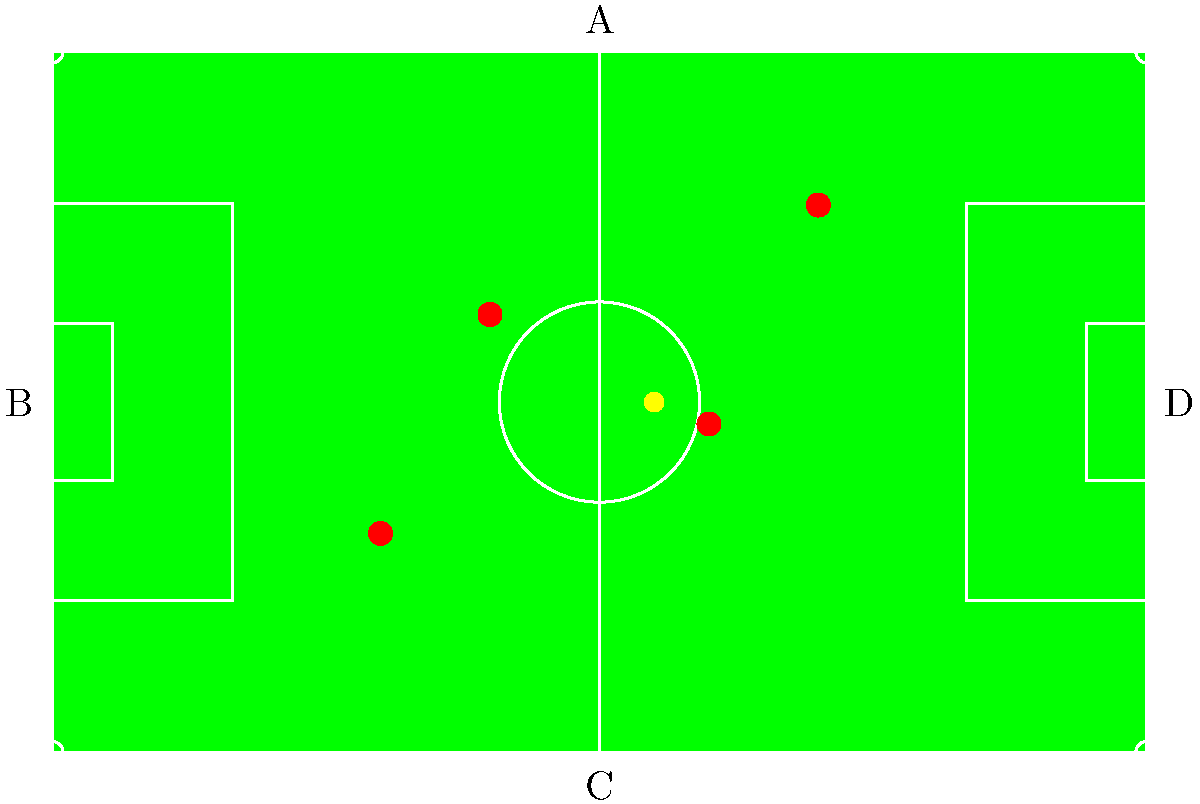As a youth soccer coach, you're planning a training session. The image shows a bird's-eye view of a soccer field with player positions and the ball. Which direction is the team facing based on the standard orientation of a soccer field? To determine the direction the team is facing, we need to follow these steps:

1. Recall the standard orientation of a soccer field:
   - The longer sides of the field are typically referred to as touchlines.
   - The shorter sides are called goal lines.
   - Teams face each other from opposite goal lines.

2. Analyze the given bird's-eye view:
   - The field is oriented with the longer sides (touchlines) vertically in the image.
   - The shorter sides (goal lines) are at the top and bottom of the image.

3. Identify key features of the field:
   - The penalty areas are rectangular boxes extending from each goal line.
   - The center circle is in the middle of the field.

4. Observe the player positions:
   - Most players are positioned in the lower half of the field.
   - This suggests they are facing towards the top of the image.

5. Consider the ball position:
   - The ball is slightly above the center circle.
   - This further supports the team's direction being towards the top of the image.

6. Conclude the team's facing direction:
   - Given the standard field orientation and player positions, the team is facing upwards in the image.
   - The direction label at the top of the image is "A".

Therefore, based on the standard orientation of a soccer field and the given bird's-eye view, the team is facing direction A.
Answer: A 